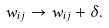Convert formula to latex. <formula><loc_0><loc_0><loc_500><loc_500>w _ { i j } \rightarrow w _ { i j } + \delta .</formula> 